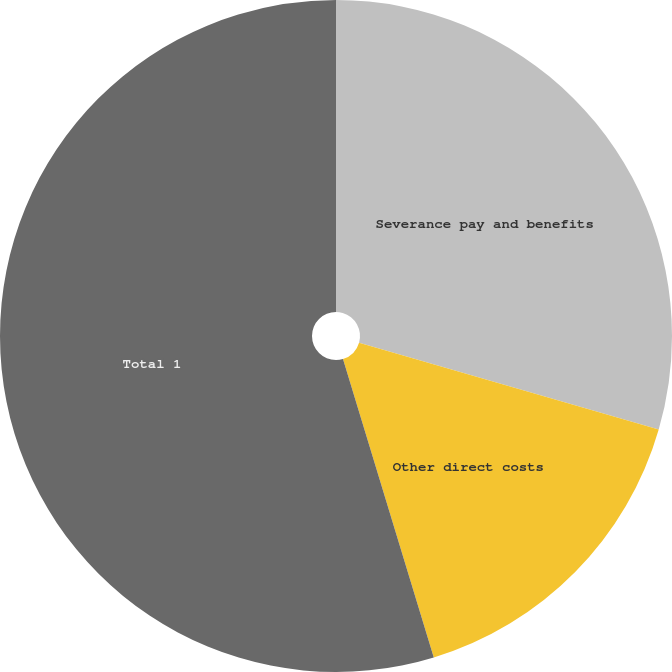Convert chart to OTSL. <chart><loc_0><loc_0><loc_500><loc_500><pie_chart><fcel>Severance pay and benefits<fcel>Other direct costs<fcel>Total 1<nl><fcel>29.49%<fcel>15.81%<fcel>54.7%<nl></chart> 